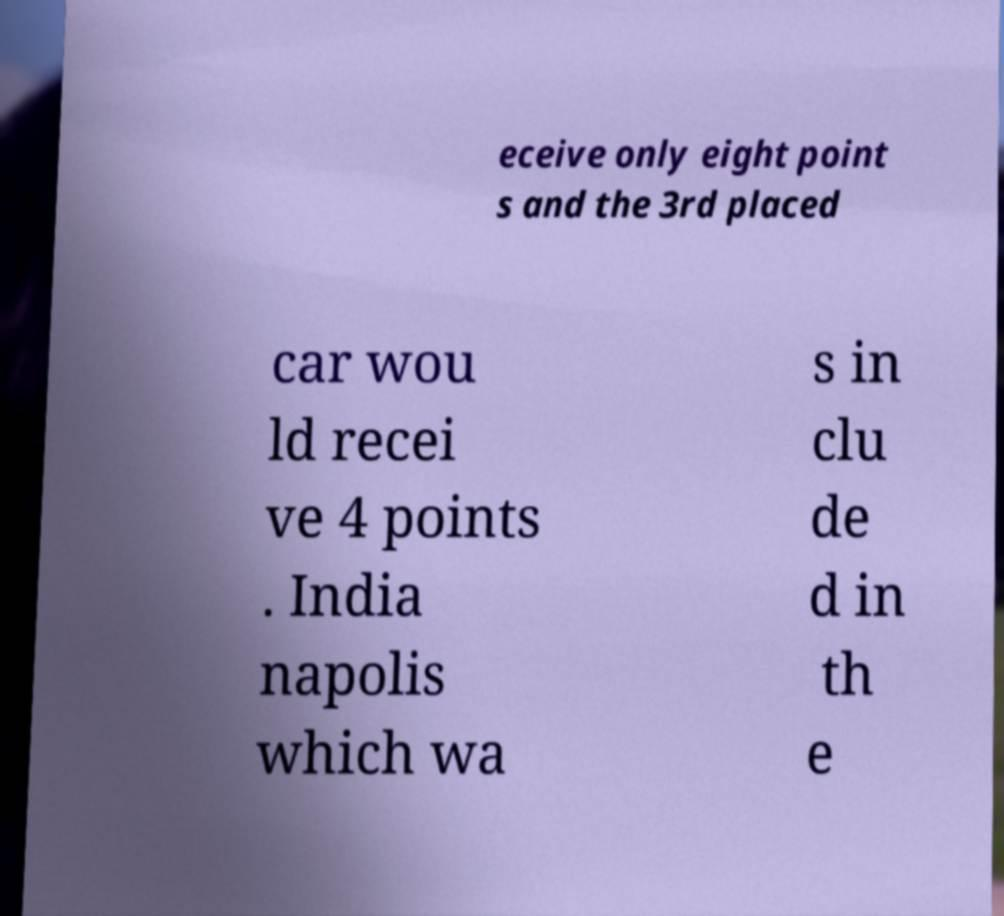What messages or text are displayed in this image? I need them in a readable, typed format. eceive only eight point s and the 3rd placed car wou ld recei ve 4 points . India napolis which wa s in clu de d in th e 